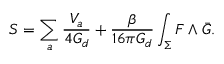Convert formula to latex. <formula><loc_0><loc_0><loc_500><loc_500>S = \sum _ { a } \frac { V _ { a } } { 4 G _ { d } } + \frac { \beta } { 1 6 \pi G _ { d } } \int _ { \Sigma } F \wedge \bar { G } .</formula> 